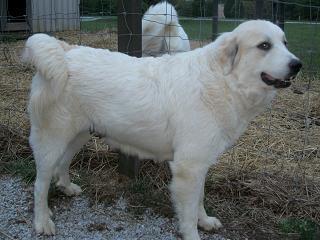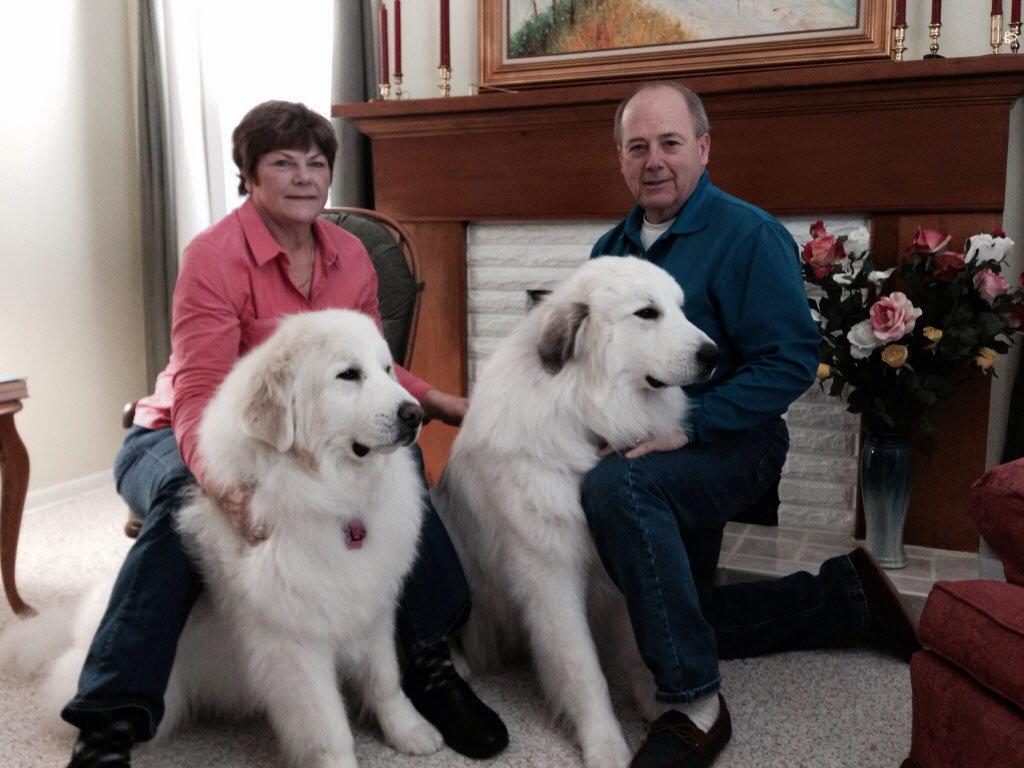The first image is the image on the left, the second image is the image on the right. Evaluate the accuracy of this statement regarding the images: "There are at least two white dogs in the right image.". Is it true? Answer yes or no. Yes. The first image is the image on the left, the second image is the image on the right. Analyze the images presented: Is the assertion "A large white dog at an outdoor setting is standing in a pose with a woman wearing jeans, who is leaning back slightly away from the dog." valid? Answer yes or no. No. 